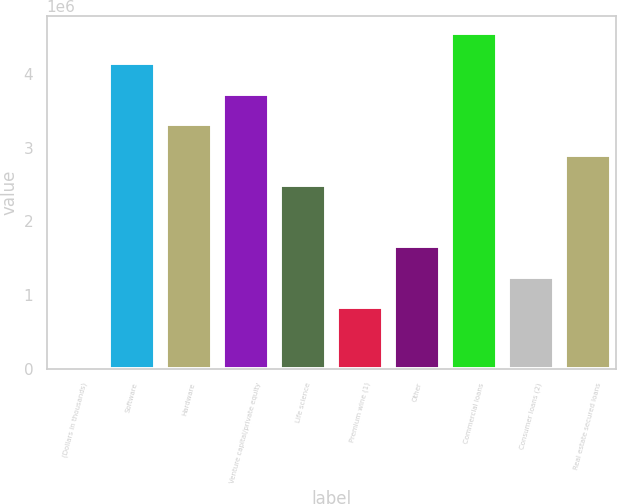Convert chart. <chart><loc_0><loc_0><loc_500><loc_500><bar_chart><fcel>(Dollars in thousands)<fcel>Software<fcel>Hardware<fcel>Venture capital/private equity<fcel>Life science<fcel>Premium wine (1)<fcel>Other<fcel>Commercial loans<fcel>Consumer loans (2)<fcel>Real estate secured loans<nl><fcel>2007<fcel>4.15173e+06<fcel>3.32179e+06<fcel>3.73676e+06<fcel>2.49184e+06<fcel>831952<fcel>1.6619e+06<fcel>4.5667e+06<fcel>1.24692e+06<fcel>2.90681e+06<nl></chart> 